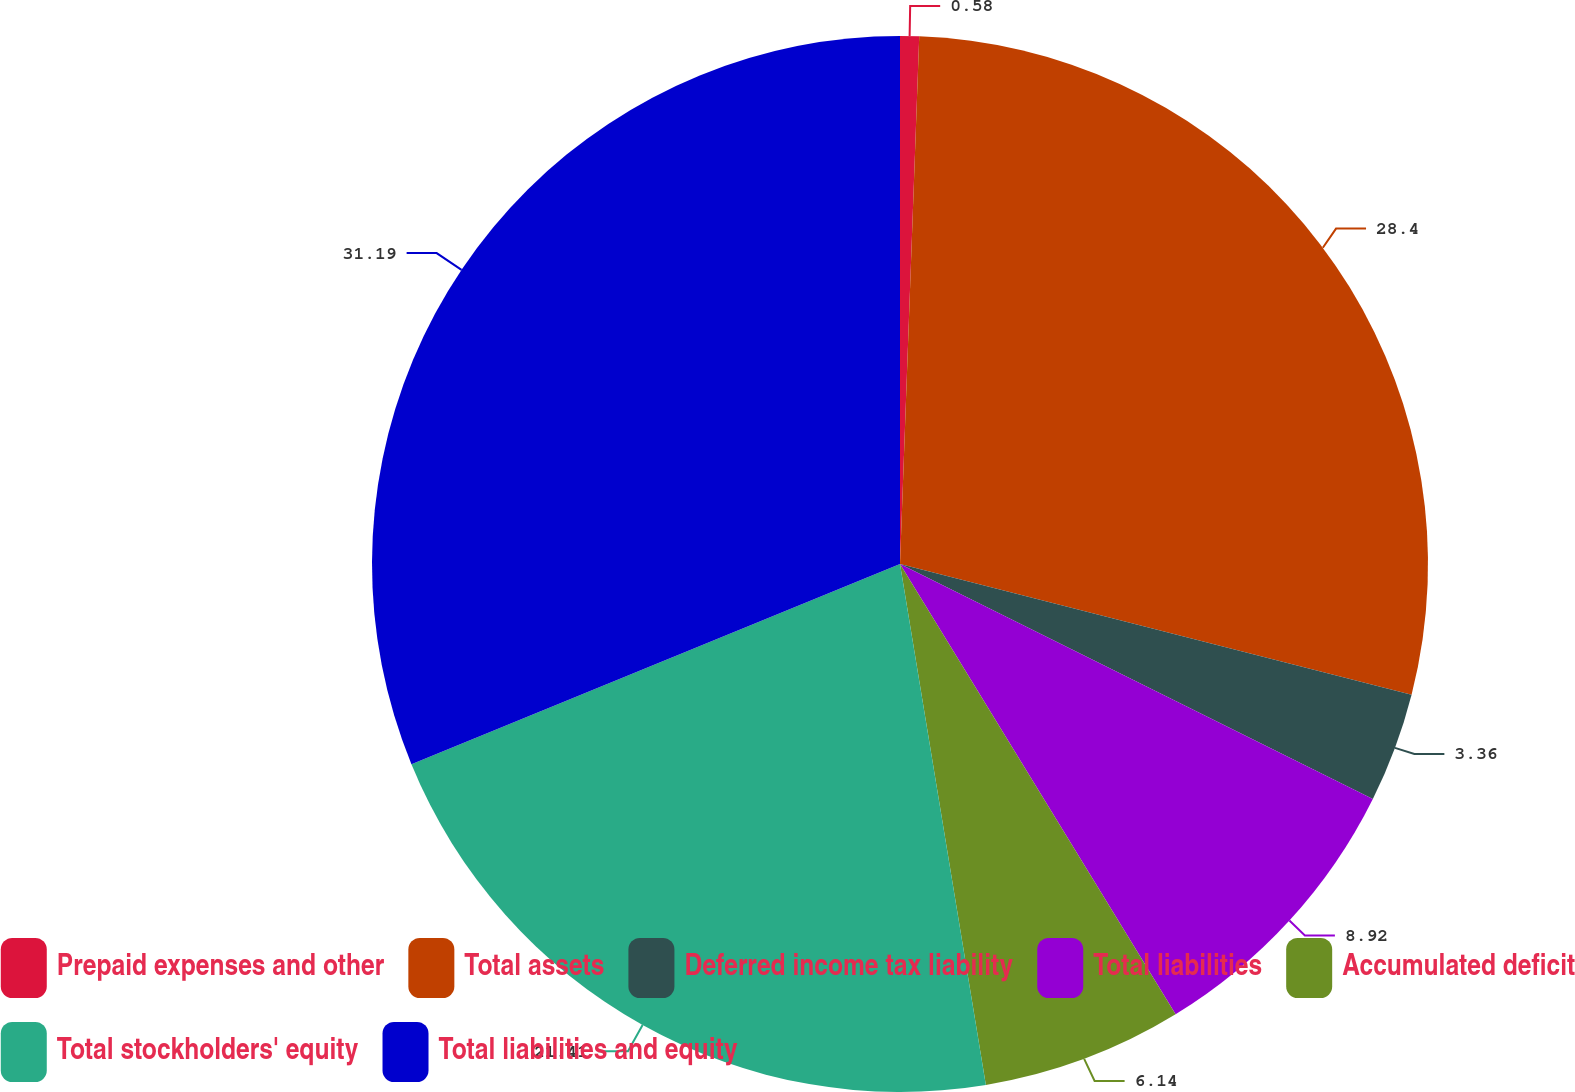Convert chart to OTSL. <chart><loc_0><loc_0><loc_500><loc_500><pie_chart><fcel>Prepaid expenses and other<fcel>Total assets<fcel>Deferred income tax liability<fcel>Total liabilities<fcel>Accumulated deficit<fcel>Total stockholders' equity<fcel>Total liabilities and equity<nl><fcel>0.58%<fcel>28.4%<fcel>3.36%<fcel>8.92%<fcel>6.14%<fcel>21.41%<fcel>31.19%<nl></chart> 